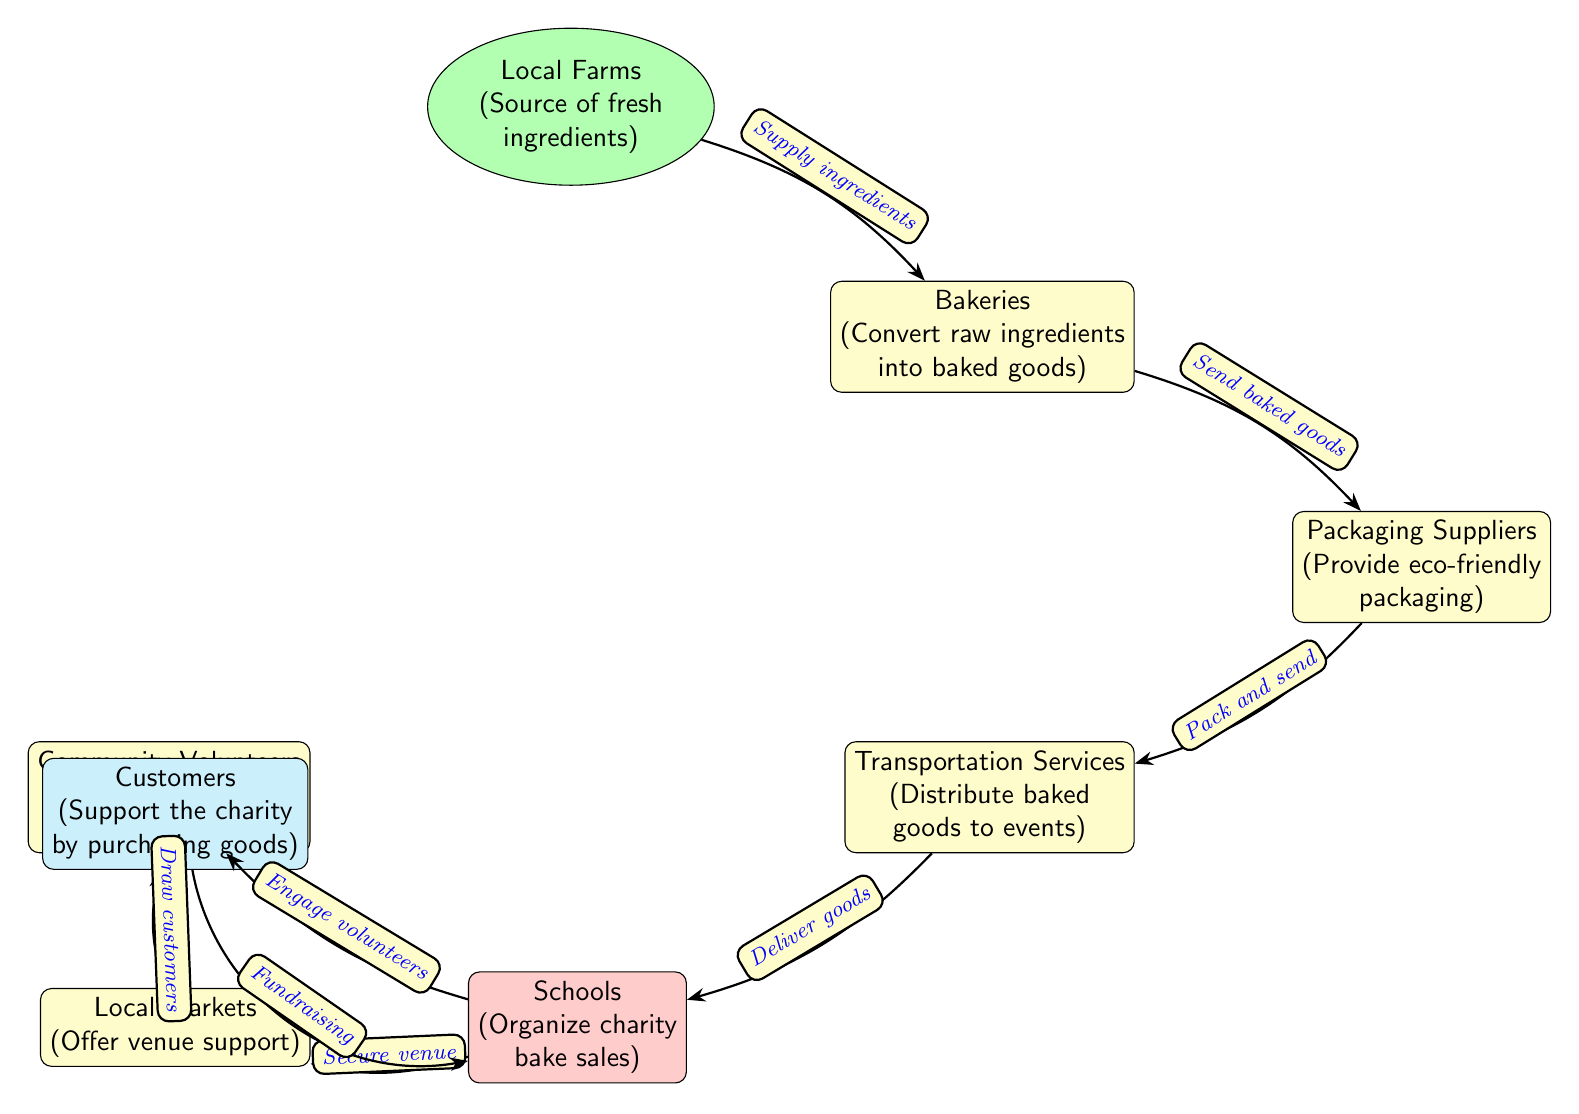What is the source of fresh ingredients? The diagram identifies the node representing the source of fresh ingredients as "Local Farms". This information is directly stated in the diagram without further elaboration.
Answer: Local Farms How many nodes are there in the diagram? By counting each unique point represented in the diagram, we see there are eight distinct nodes, each corresponding to a role within the food chain supporting the charity bake sales.
Answer: 8 Who provides eco-friendly packaging? The role of providing eco-friendly packaging is attributed to the "Packaging Suppliers" node, which is explicitly labeled in the diagram, indicating its specific function in the process.
Answer: Packaging Suppliers What is the relationship between bakeries and transportation services? The diagram shows that bakeries send baked goods to transportation services, which is a direct edge connecting the two nodes. This relationship illustrates the flow of goods from one stage to another.
Answer: Send baked goods Which entities engage volunteers for event operations? According to the diagram, the "Schools" node is responsible for engaging volunteers, as shown by the directional edge leading from schools to community volunteers. This clarifies the primary role of schools in organizing charity bake sales.
Answer: Schools What role do customers play in the charity bake sale process? The diagram indicates that customers support the charity by purchasing goods, which emphasizes their critical role in the fundraising aspect of the bake sale event.
Answer: Support the charity How do local markets contribute to charity events? The contribution of local markets is shown as providing venue support, which connects them to the schools node, indicating how these markets facilitate the logistics of the event.
Answer: Offer venue support What happens after baked goods are packaged? Following the packaging of baked goods, the diagram shows that they are sent to transportation services, which signifies the next step in the distribution chain for the charity bake sale.
Answer: Pack and send Which node is positioned above the schools node in the diagram? The positioning of the nodes indicates that the "Community Volunteers" node is located above the "Schools" node, highlighting its role in supporting the operational aspects of the charity bake sale.
Answer: Community Volunteers What type of relationship do customers have with schools? The relationship is depicted as a "Fundraising" connection, which indicates that the actions of customers directly contribute to the schools' fundraising efforts through their purchases.
Answer: Fundraising 